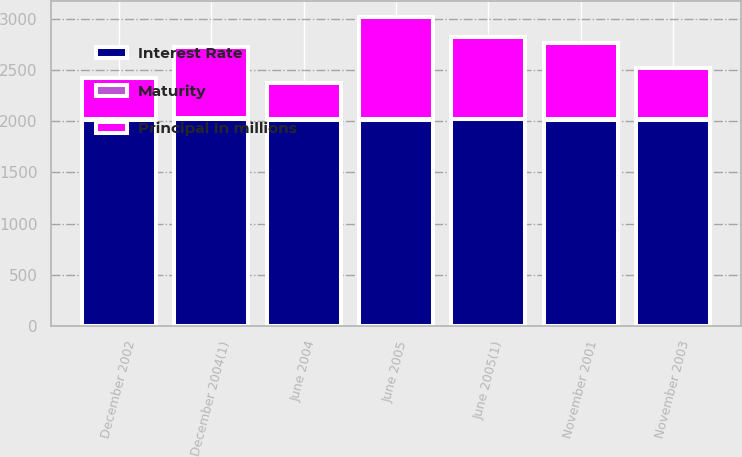Convert chart to OTSL. <chart><loc_0><loc_0><loc_500><loc_500><stacked_bar_chart><ecel><fcel>June 2005<fcel>June 2005(1)<fcel>December 2004(1)<fcel>June 2004<fcel>November 2003<fcel>December 2002<fcel>November 2001<nl><fcel>Principal In millions<fcel>1000<fcel>794<fcel>695<fcel>350<fcel>500<fcel>400<fcel>750<nl><fcel>Maturity<fcel>5<fcel>5.25<fcel>5.38<fcel>5.5<fcel>5<fcel>5.38<fcel>6.13<nl><fcel>Interest Rate<fcel>2015<fcel>2020<fcel>2024<fcel>2014<fcel>2013<fcel>2012<fcel>2011<nl></chart> 